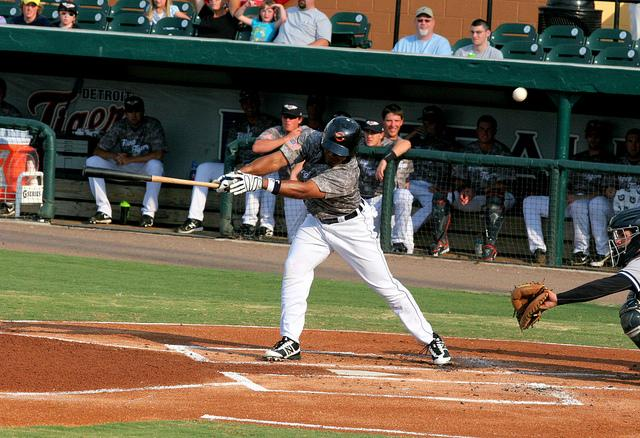What is the man with the bat about to do? run 